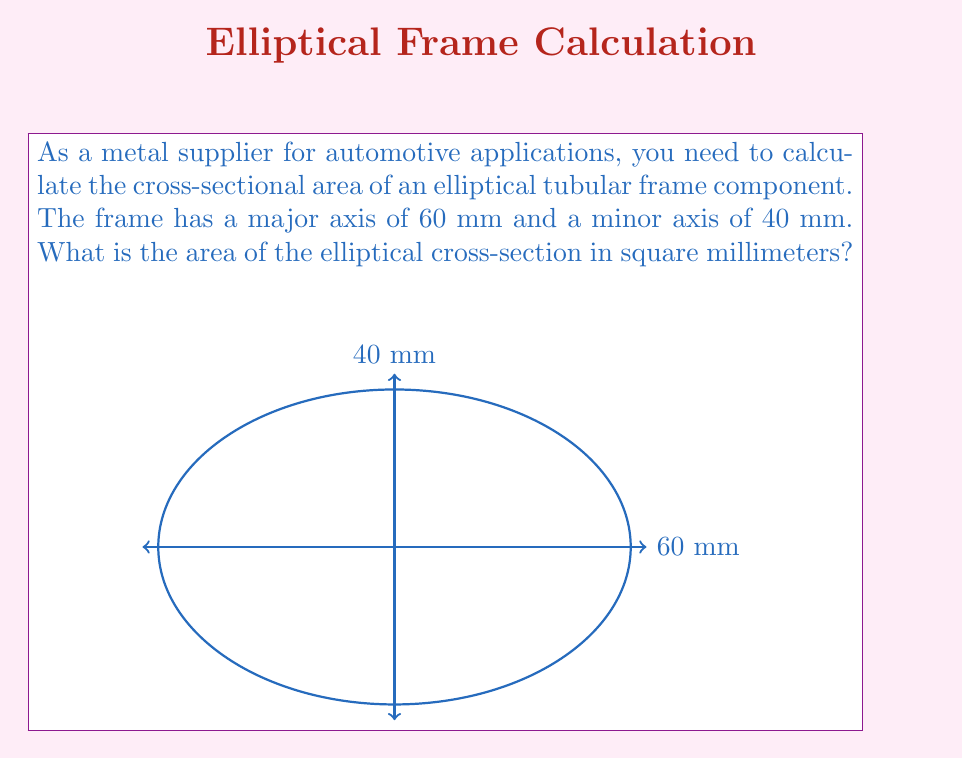What is the answer to this math problem? To calculate the area of an elliptical cross-section, we use the formula:

$$A = \pi ab$$

Where:
$A$ = area of the ellipse
$a$ = length of the semi-major axis
$b$ = length of the semi-minor axis
$\pi$ ≈ 3.14159

Given:
- Major axis = 60 mm
- Minor axis = 40 mm

Step 1: Calculate the semi-major and semi-minor axes
Semi-major axis, $a = 60 \div 2 = 30$ mm
Semi-minor axis, $b = 40 \div 2 = 20$ mm

Step 2: Apply the formula
$$A = \pi ab$$
$$A = \pi(30)(20)$$

Step 3: Calculate the result
$$A = 3.14159 \times 30 \times 20$$
$$A = 1884.954 \text{ mm}^2$$

Step 4: Round to the nearest whole number
$$A \approx 1885 \text{ mm}^2$$
Answer: $1885 \text{ mm}^2$ 